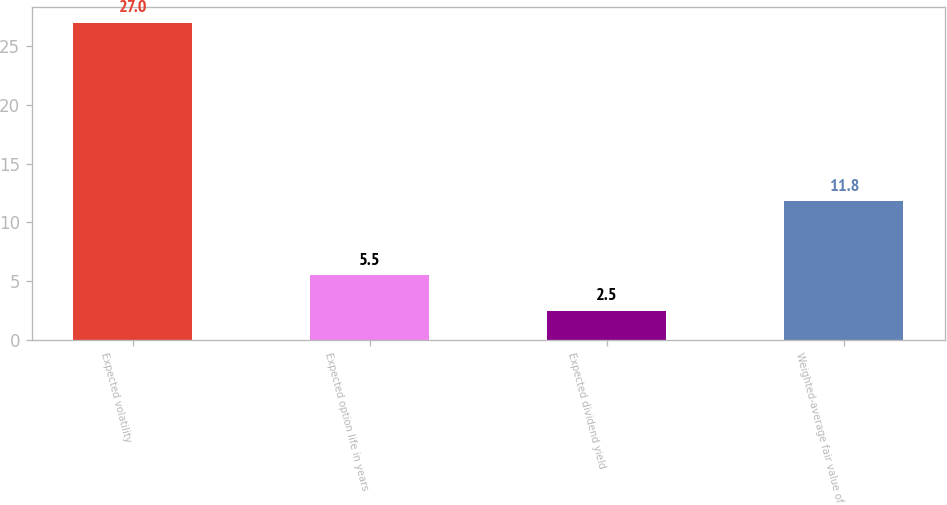<chart> <loc_0><loc_0><loc_500><loc_500><bar_chart><fcel>Expected volatility<fcel>Expected option life in years<fcel>Expected dividend yield<fcel>Weighted-average fair value of<nl><fcel>27<fcel>5.5<fcel>2.5<fcel>11.8<nl></chart> 